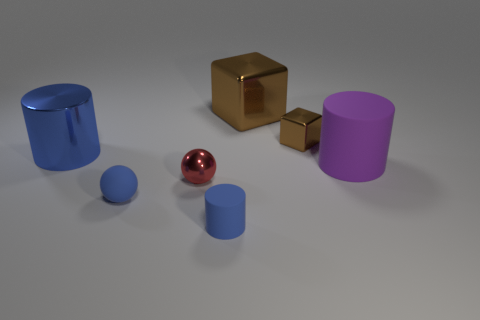Is the large blue object the same shape as the big purple thing?
Offer a very short reply. Yes. How many cylinders are either large purple objects or tiny blue things?
Offer a terse response. 2. The sphere that is made of the same material as the large purple thing is what color?
Give a very brief answer. Blue. Do the blue object behind the red ball and the tiny red metallic ball have the same size?
Offer a terse response. No. Are the blue sphere and the cylinder that is on the left side of the red metal thing made of the same material?
Give a very brief answer. No. There is a big cylinder that is to the right of the small metal ball; what color is it?
Make the answer very short. Purple. Are there any big metal cylinders on the right side of the object in front of the blue rubber ball?
Keep it short and to the point. No. Does the big thing left of the small matte cylinder have the same color as the tiny matte thing on the left side of the tiny metal sphere?
Make the answer very short. Yes. What number of tiny matte cylinders are behind the large metallic block?
Ensure brevity in your answer.  0. How many tiny things are the same color as the tiny matte cylinder?
Ensure brevity in your answer.  1. 